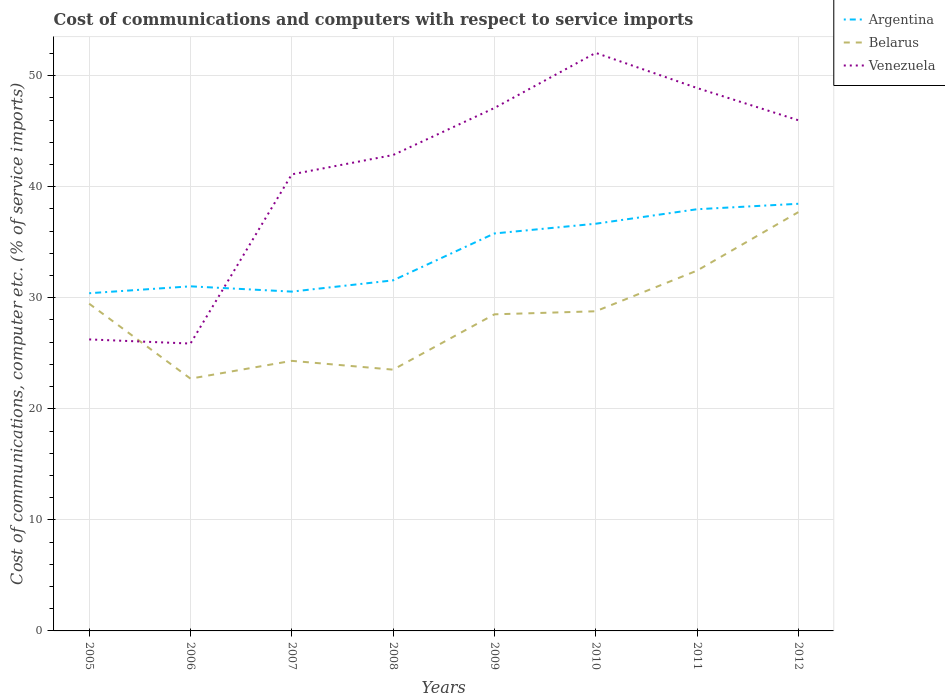How many different coloured lines are there?
Provide a succinct answer. 3. Does the line corresponding to Venezuela intersect with the line corresponding to Belarus?
Make the answer very short. Yes. Is the number of lines equal to the number of legend labels?
Your answer should be very brief. Yes. Across all years, what is the maximum cost of communications and computers in Argentina?
Offer a terse response. 30.41. In which year was the cost of communications and computers in Venezuela maximum?
Keep it short and to the point. 2006. What is the total cost of communications and computers in Belarus in the graph?
Offer a terse response. -1.6. What is the difference between the highest and the second highest cost of communications and computers in Argentina?
Offer a terse response. 8.05. What is the difference between the highest and the lowest cost of communications and computers in Argentina?
Your response must be concise. 4. Is the cost of communications and computers in Argentina strictly greater than the cost of communications and computers in Venezuela over the years?
Your response must be concise. No. What is the difference between two consecutive major ticks on the Y-axis?
Give a very brief answer. 10. Are the values on the major ticks of Y-axis written in scientific E-notation?
Make the answer very short. No. Does the graph contain grids?
Your answer should be compact. Yes. Where does the legend appear in the graph?
Your answer should be compact. Top right. How many legend labels are there?
Provide a short and direct response. 3. How are the legend labels stacked?
Offer a very short reply. Vertical. What is the title of the graph?
Give a very brief answer. Cost of communications and computers with respect to service imports. Does "Bangladesh" appear as one of the legend labels in the graph?
Your answer should be very brief. No. What is the label or title of the X-axis?
Your answer should be compact. Years. What is the label or title of the Y-axis?
Make the answer very short. Cost of communications, computer etc. (% of service imports). What is the Cost of communications, computer etc. (% of service imports) in Argentina in 2005?
Provide a short and direct response. 30.41. What is the Cost of communications, computer etc. (% of service imports) of Belarus in 2005?
Keep it short and to the point. 29.47. What is the Cost of communications, computer etc. (% of service imports) in Venezuela in 2005?
Your response must be concise. 26.25. What is the Cost of communications, computer etc. (% of service imports) in Argentina in 2006?
Your response must be concise. 31.03. What is the Cost of communications, computer etc. (% of service imports) of Belarus in 2006?
Provide a short and direct response. 22.72. What is the Cost of communications, computer etc. (% of service imports) in Venezuela in 2006?
Keep it short and to the point. 25.88. What is the Cost of communications, computer etc. (% of service imports) in Argentina in 2007?
Ensure brevity in your answer.  30.55. What is the Cost of communications, computer etc. (% of service imports) of Belarus in 2007?
Provide a short and direct response. 24.32. What is the Cost of communications, computer etc. (% of service imports) of Venezuela in 2007?
Your answer should be compact. 41.11. What is the Cost of communications, computer etc. (% of service imports) of Argentina in 2008?
Make the answer very short. 31.57. What is the Cost of communications, computer etc. (% of service imports) in Belarus in 2008?
Your answer should be very brief. 23.53. What is the Cost of communications, computer etc. (% of service imports) in Venezuela in 2008?
Provide a succinct answer. 42.85. What is the Cost of communications, computer etc. (% of service imports) in Argentina in 2009?
Provide a succinct answer. 35.79. What is the Cost of communications, computer etc. (% of service imports) in Belarus in 2009?
Your answer should be very brief. 28.51. What is the Cost of communications, computer etc. (% of service imports) of Venezuela in 2009?
Offer a terse response. 47.09. What is the Cost of communications, computer etc. (% of service imports) in Argentina in 2010?
Keep it short and to the point. 36.67. What is the Cost of communications, computer etc. (% of service imports) of Belarus in 2010?
Offer a terse response. 28.78. What is the Cost of communications, computer etc. (% of service imports) of Venezuela in 2010?
Offer a very short reply. 52.05. What is the Cost of communications, computer etc. (% of service imports) of Argentina in 2011?
Make the answer very short. 37.97. What is the Cost of communications, computer etc. (% of service imports) in Belarus in 2011?
Provide a short and direct response. 32.44. What is the Cost of communications, computer etc. (% of service imports) of Venezuela in 2011?
Offer a terse response. 48.89. What is the Cost of communications, computer etc. (% of service imports) in Argentina in 2012?
Give a very brief answer. 38.46. What is the Cost of communications, computer etc. (% of service imports) in Belarus in 2012?
Provide a short and direct response. 37.71. What is the Cost of communications, computer etc. (% of service imports) of Venezuela in 2012?
Ensure brevity in your answer.  45.98. Across all years, what is the maximum Cost of communications, computer etc. (% of service imports) of Argentina?
Provide a short and direct response. 38.46. Across all years, what is the maximum Cost of communications, computer etc. (% of service imports) in Belarus?
Provide a succinct answer. 37.71. Across all years, what is the maximum Cost of communications, computer etc. (% of service imports) of Venezuela?
Give a very brief answer. 52.05. Across all years, what is the minimum Cost of communications, computer etc. (% of service imports) of Argentina?
Make the answer very short. 30.41. Across all years, what is the minimum Cost of communications, computer etc. (% of service imports) in Belarus?
Your answer should be compact. 22.72. Across all years, what is the minimum Cost of communications, computer etc. (% of service imports) of Venezuela?
Offer a very short reply. 25.88. What is the total Cost of communications, computer etc. (% of service imports) of Argentina in the graph?
Offer a very short reply. 272.45. What is the total Cost of communications, computer etc. (% of service imports) of Belarus in the graph?
Keep it short and to the point. 227.47. What is the total Cost of communications, computer etc. (% of service imports) in Venezuela in the graph?
Keep it short and to the point. 330.1. What is the difference between the Cost of communications, computer etc. (% of service imports) in Argentina in 2005 and that in 2006?
Provide a succinct answer. -0.62. What is the difference between the Cost of communications, computer etc. (% of service imports) in Belarus in 2005 and that in 2006?
Offer a terse response. 6.75. What is the difference between the Cost of communications, computer etc. (% of service imports) in Venezuela in 2005 and that in 2006?
Provide a succinct answer. 0.37. What is the difference between the Cost of communications, computer etc. (% of service imports) in Argentina in 2005 and that in 2007?
Provide a succinct answer. -0.15. What is the difference between the Cost of communications, computer etc. (% of service imports) in Belarus in 2005 and that in 2007?
Your answer should be compact. 5.15. What is the difference between the Cost of communications, computer etc. (% of service imports) in Venezuela in 2005 and that in 2007?
Provide a short and direct response. -14.86. What is the difference between the Cost of communications, computer etc. (% of service imports) of Argentina in 2005 and that in 2008?
Keep it short and to the point. -1.16. What is the difference between the Cost of communications, computer etc. (% of service imports) in Belarus in 2005 and that in 2008?
Your answer should be compact. 5.94. What is the difference between the Cost of communications, computer etc. (% of service imports) of Venezuela in 2005 and that in 2008?
Provide a short and direct response. -16.6. What is the difference between the Cost of communications, computer etc. (% of service imports) of Argentina in 2005 and that in 2009?
Keep it short and to the point. -5.38. What is the difference between the Cost of communications, computer etc. (% of service imports) in Belarus in 2005 and that in 2009?
Your response must be concise. 0.96. What is the difference between the Cost of communications, computer etc. (% of service imports) of Venezuela in 2005 and that in 2009?
Your answer should be compact. -20.84. What is the difference between the Cost of communications, computer etc. (% of service imports) in Argentina in 2005 and that in 2010?
Offer a very short reply. -6.26. What is the difference between the Cost of communications, computer etc. (% of service imports) in Belarus in 2005 and that in 2010?
Make the answer very short. 0.68. What is the difference between the Cost of communications, computer etc. (% of service imports) in Venezuela in 2005 and that in 2010?
Your answer should be very brief. -25.8. What is the difference between the Cost of communications, computer etc. (% of service imports) in Argentina in 2005 and that in 2011?
Give a very brief answer. -7.56. What is the difference between the Cost of communications, computer etc. (% of service imports) in Belarus in 2005 and that in 2011?
Your answer should be very brief. -2.98. What is the difference between the Cost of communications, computer etc. (% of service imports) in Venezuela in 2005 and that in 2011?
Ensure brevity in your answer.  -22.64. What is the difference between the Cost of communications, computer etc. (% of service imports) in Argentina in 2005 and that in 2012?
Offer a terse response. -8.05. What is the difference between the Cost of communications, computer etc. (% of service imports) of Belarus in 2005 and that in 2012?
Your response must be concise. -8.24. What is the difference between the Cost of communications, computer etc. (% of service imports) in Venezuela in 2005 and that in 2012?
Provide a succinct answer. -19.73. What is the difference between the Cost of communications, computer etc. (% of service imports) of Argentina in 2006 and that in 2007?
Give a very brief answer. 0.48. What is the difference between the Cost of communications, computer etc. (% of service imports) in Belarus in 2006 and that in 2007?
Give a very brief answer. -1.6. What is the difference between the Cost of communications, computer etc. (% of service imports) in Venezuela in 2006 and that in 2007?
Your answer should be compact. -15.24. What is the difference between the Cost of communications, computer etc. (% of service imports) in Argentina in 2006 and that in 2008?
Offer a terse response. -0.54. What is the difference between the Cost of communications, computer etc. (% of service imports) of Belarus in 2006 and that in 2008?
Make the answer very short. -0.81. What is the difference between the Cost of communications, computer etc. (% of service imports) of Venezuela in 2006 and that in 2008?
Give a very brief answer. -16.98. What is the difference between the Cost of communications, computer etc. (% of service imports) of Argentina in 2006 and that in 2009?
Provide a short and direct response. -4.76. What is the difference between the Cost of communications, computer etc. (% of service imports) of Belarus in 2006 and that in 2009?
Ensure brevity in your answer.  -5.79. What is the difference between the Cost of communications, computer etc. (% of service imports) in Venezuela in 2006 and that in 2009?
Your answer should be compact. -21.21. What is the difference between the Cost of communications, computer etc. (% of service imports) of Argentina in 2006 and that in 2010?
Your response must be concise. -5.64. What is the difference between the Cost of communications, computer etc. (% of service imports) of Belarus in 2006 and that in 2010?
Make the answer very short. -6.07. What is the difference between the Cost of communications, computer etc. (% of service imports) of Venezuela in 2006 and that in 2010?
Your answer should be compact. -26.18. What is the difference between the Cost of communications, computer etc. (% of service imports) in Argentina in 2006 and that in 2011?
Provide a succinct answer. -6.94. What is the difference between the Cost of communications, computer etc. (% of service imports) of Belarus in 2006 and that in 2011?
Your answer should be compact. -9.73. What is the difference between the Cost of communications, computer etc. (% of service imports) in Venezuela in 2006 and that in 2011?
Keep it short and to the point. -23.01. What is the difference between the Cost of communications, computer etc. (% of service imports) in Argentina in 2006 and that in 2012?
Keep it short and to the point. -7.43. What is the difference between the Cost of communications, computer etc. (% of service imports) in Belarus in 2006 and that in 2012?
Ensure brevity in your answer.  -14.99. What is the difference between the Cost of communications, computer etc. (% of service imports) in Venezuela in 2006 and that in 2012?
Offer a terse response. -20.11. What is the difference between the Cost of communications, computer etc. (% of service imports) of Argentina in 2007 and that in 2008?
Offer a terse response. -1.01. What is the difference between the Cost of communications, computer etc. (% of service imports) in Belarus in 2007 and that in 2008?
Provide a short and direct response. 0.79. What is the difference between the Cost of communications, computer etc. (% of service imports) in Venezuela in 2007 and that in 2008?
Make the answer very short. -1.74. What is the difference between the Cost of communications, computer etc. (% of service imports) in Argentina in 2007 and that in 2009?
Offer a very short reply. -5.24. What is the difference between the Cost of communications, computer etc. (% of service imports) in Belarus in 2007 and that in 2009?
Provide a short and direct response. -4.19. What is the difference between the Cost of communications, computer etc. (% of service imports) of Venezuela in 2007 and that in 2009?
Provide a short and direct response. -5.97. What is the difference between the Cost of communications, computer etc. (% of service imports) of Argentina in 2007 and that in 2010?
Provide a succinct answer. -6.11. What is the difference between the Cost of communications, computer etc. (% of service imports) of Belarus in 2007 and that in 2010?
Your answer should be compact. -4.46. What is the difference between the Cost of communications, computer etc. (% of service imports) in Venezuela in 2007 and that in 2010?
Your answer should be very brief. -10.94. What is the difference between the Cost of communications, computer etc. (% of service imports) of Argentina in 2007 and that in 2011?
Keep it short and to the point. -7.42. What is the difference between the Cost of communications, computer etc. (% of service imports) of Belarus in 2007 and that in 2011?
Make the answer very short. -8.13. What is the difference between the Cost of communications, computer etc. (% of service imports) of Venezuela in 2007 and that in 2011?
Ensure brevity in your answer.  -7.77. What is the difference between the Cost of communications, computer etc. (% of service imports) of Argentina in 2007 and that in 2012?
Give a very brief answer. -7.91. What is the difference between the Cost of communications, computer etc. (% of service imports) of Belarus in 2007 and that in 2012?
Offer a terse response. -13.39. What is the difference between the Cost of communications, computer etc. (% of service imports) of Venezuela in 2007 and that in 2012?
Your answer should be compact. -4.87. What is the difference between the Cost of communications, computer etc. (% of service imports) in Argentina in 2008 and that in 2009?
Keep it short and to the point. -4.22. What is the difference between the Cost of communications, computer etc. (% of service imports) in Belarus in 2008 and that in 2009?
Offer a terse response. -4.98. What is the difference between the Cost of communications, computer etc. (% of service imports) in Venezuela in 2008 and that in 2009?
Your answer should be compact. -4.23. What is the difference between the Cost of communications, computer etc. (% of service imports) of Argentina in 2008 and that in 2010?
Your answer should be compact. -5.1. What is the difference between the Cost of communications, computer etc. (% of service imports) in Belarus in 2008 and that in 2010?
Your answer should be very brief. -5.26. What is the difference between the Cost of communications, computer etc. (% of service imports) in Venezuela in 2008 and that in 2010?
Keep it short and to the point. -9.2. What is the difference between the Cost of communications, computer etc. (% of service imports) in Argentina in 2008 and that in 2011?
Offer a very short reply. -6.4. What is the difference between the Cost of communications, computer etc. (% of service imports) in Belarus in 2008 and that in 2011?
Keep it short and to the point. -8.92. What is the difference between the Cost of communications, computer etc. (% of service imports) of Venezuela in 2008 and that in 2011?
Make the answer very short. -6.03. What is the difference between the Cost of communications, computer etc. (% of service imports) of Argentina in 2008 and that in 2012?
Ensure brevity in your answer.  -6.9. What is the difference between the Cost of communications, computer etc. (% of service imports) in Belarus in 2008 and that in 2012?
Give a very brief answer. -14.18. What is the difference between the Cost of communications, computer etc. (% of service imports) of Venezuela in 2008 and that in 2012?
Ensure brevity in your answer.  -3.13. What is the difference between the Cost of communications, computer etc. (% of service imports) of Argentina in 2009 and that in 2010?
Ensure brevity in your answer.  -0.88. What is the difference between the Cost of communications, computer etc. (% of service imports) in Belarus in 2009 and that in 2010?
Provide a succinct answer. -0.28. What is the difference between the Cost of communications, computer etc. (% of service imports) of Venezuela in 2009 and that in 2010?
Provide a succinct answer. -4.96. What is the difference between the Cost of communications, computer etc. (% of service imports) of Argentina in 2009 and that in 2011?
Give a very brief answer. -2.18. What is the difference between the Cost of communications, computer etc. (% of service imports) of Belarus in 2009 and that in 2011?
Offer a very short reply. -3.94. What is the difference between the Cost of communications, computer etc. (% of service imports) in Venezuela in 2009 and that in 2011?
Your response must be concise. -1.8. What is the difference between the Cost of communications, computer etc. (% of service imports) of Argentina in 2009 and that in 2012?
Provide a short and direct response. -2.67. What is the difference between the Cost of communications, computer etc. (% of service imports) of Belarus in 2009 and that in 2012?
Give a very brief answer. -9.2. What is the difference between the Cost of communications, computer etc. (% of service imports) in Venezuela in 2009 and that in 2012?
Give a very brief answer. 1.1. What is the difference between the Cost of communications, computer etc. (% of service imports) in Argentina in 2010 and that in 2011?
Provide a short and direct response. -1.3. What is the difference between the Cost of communications, computer etc. (% of service imports) of Belarus in 2010 and that in 2011?
Your answer should be compact. -3.66. What is the difference between the Cost of communications, computer etc. (% of service imports) of Venezuela in 2010 and that in 2011?
Your answer should be very brief. 3.16. What is the difference between the Cost of communications, computer etc. (% of service imports) in Argentina in 2010 and that in 2012?
Give a very brief answer. -1.8. What is the difference between the Cost of communications, computer etc. (% of service imports) of Belarus in 2010 and that in 2012?
Offer a terse response. -8.93. What is the difference between the Cost of communications, computer etc. (% of service imports) of Venezuela in 2010 and that in 2012?
Ensure brevity in your answer.  6.07. What is the difference between the Cost of communications, computer etc. (% of service imports) of Argentina in 2011 and that in 2012?
Offer a terse response. -0.49. What is the difference between the Cost of communications, computer etc. (% of service imports) in Belarus in 2011 and that in 2012?
Offer a very short reply. -5.26. What is the difference between the Cost of communications, computer etc. (% of service imports) of Venezuela in 2011 and that in 2012?
Your answer should be compact. 2.9. What is the difference between the Cost of communications, computer etc. (% of service imports) in Argentina in 2005 and the Cost of communications, computer etc. (% of service imports) in Belarus in 2006?
Your answer should be compact. 7.69. What is the difference between the Cost of communications, computer etc. (% of service imports) of Argentina in 2005 and the Cost of communications, computer etc. (% of service imports) of Venezuela in 2006?
Offer a terse response. 4.53. What is the difference between the Cost of communications, computer etc. (% of service imports) of Belarus in 2005 and the Cost of communications, computer etc. (% of service imports) of Venezuela in 2006?
Your answer should be compact. 3.59. What is the difference between the Cost of communications, computer etc. (% of service imports) of Argentina in 2005 and the Cost of communications, computer etc. (% of service imports) of Belarus in 2007?
Provide a short and direct response. 6.09. What is the difference between the Cost of communications, computer etc. (% of service imports) in Argentina in 2005 and the Cost of communications, computer etc. (% of service imports) in Venezuela in 2007?
Provide a short and direct response. -10.7. What is the difference between the Cost of communications, computer etc. (% of service imports) in Belarus in 2005 and the Cost of communications, computer etc. (% of service imports) in Venezuela in 2007?
Your response must be concise. -11.65. What is the difference between the Cost of communications, computer etc. (% of service imports) of Argentina in 2005 and the Cost of communications, computer etc. (% of service imports) of Belarus in 2008?
Provide a short and direct response. 6.88. What is the difference between the Cost of communications, computer etc. (% of service imports) in Argentina in 2005 and the Cost of communications, computer etc. (% of service imports) in Venezuela in 2008?
Your response must be concise. -12.45. What is the difference between the Cost of communications, computer etc. (% of service imports) of Belarus in 2005 and the Cost of communications, computer etc. (% of service imports) of Venezuela in 2008?
Your answer should be very brief. -13.39. What is the difference between the Cost of communications, computer etc. (% of service imports) in Argentina in 2005 and the Cost of communications, computer etc. (% of service imports) in Belarus in 2009?
Your answer should be very brief. 1.9. What is the difference between the Cost of communications, computer etc. (% of service imports) of Argentina in 2005 and the Cost of communications, computer etc. (% of service imports) of Venezuela in 2009?
Provide a short and direct response. -16.68. What is the difference between the Cost of communications, computer etc. (% of service imports) of Belarus in 2005 and the Cost of communications, computer etc. (% of service imports) of Venezuela in 2009?
Make the answer very short. -17.62. What is the difference between the Cost of communications, computer etc. (% of service imports) of Argentina in 2005 and the Cost of communications, computer etc. (% of service imports) of Belarus in 2010?
Keep it short and to the point. 1.62. What is the difference between the Cost of communications, computer etc. (% of service imports) of Argentina in 2005 and the Cost of communications, computer etc. (% of service imports) of Venezuela in 2010?
Ensure brevity in your answer.  -21.64. What is the difference between the Cost of communications, computer etc. (% of service imports) in Belarus in 2005 and the Cost of communications, computer etc. (% of service imports) in Venezuela in 2010?
Provide a short and direct response. -22.59. What is the difference between the Cost of communications, computer etc. (% of service imports) of Argentina in 2005 and the Cost of communications, computer etc. (% of service imports) of Belarus in 2011?
Keep it short and to the point. -2.04. What is the difference between the Cost of communications, computer etc. (% of service imports) in Argentina in 2005 and the Cost of communications, computer etc. (% of service imports) in Venezuela in 2011?
Your answer should be compact. -18.48. What is the difference between the Cost of communications, computer etc. (% of service imports) in Belarus in 2005 and the Cost of communications, computer etc. (% of service imports) in Venezuela in 2011?
Offer a very short reply. -19.42. What is the difference between the Cost of communications, computer etc. (% of service imports) in Argentina in 2005 and the Cost of communications, computer etc. (% of service imports) in Belarus in 2012?
Your answer should be compact. -7.3. What is the difference between the Cost of communications, computer etc. (% of service imports) in Argentina in 2005 and the Cost of communications, computer etc. (% of service imports) in Venezuela in 2012?
Provide a succinct answer. -15.58. What is the difference between the Cost of communications, computer etc. (% of service imports) in Belarus in 2005 and the Cost of communications, computer etc. (% of service imports) in Venezuela in 2012?
Provide a succinct answer. -16.52. What is the difference between the Cost of communications, computer etc. (% of service imports) in Argentina in 2006 and the Cost of communications, computer etc. (% of service imports) in Belarus in 2007?
Make the answer very short. 6.71. What is the difference between the Cost of communications, computer etc. (% of service imports) in Argentina in 2006 and the Cost of communications, computer etc. (% of service imports) in Venezuela in 2007?
Offer a very short reply. -10.08. What is the difference between the Cost of communications, computer etc. (% of service imports) of Belarus in 2006 and the Cost of communications, computer etc. (% of service imports) of Venezuela in 2007?
Offer a terse response. -18.4. What is the difference between the Cost of communications, computer etc. (% of service imports) of Argentina in 2006 and the Cost of communications, computer etc. (% of service imports) of Belarus in 2008?
Ensure brevity in your answer.  7.5. What is the difference between the Cost of communications, computer etc. (% of service imports) in Argentina in 2006 and the Cost of communications, computer etc. (% of service imports) in Venezuela in 2008?
Give a very brief answer. -11.82. What is the difference between the Cost of communications, computer etc. (% of service imports) of Belarus in 2006 and the Cost of communications, computer etc. (% of service imports) of Venezuela in 2008?
Provide a succinct answer. -20.14. What is the difference between the Cost of communications, computer etc. (% of service imports) in Argentina in 2006 and the Cost of communications, computer etc. (% of service imports) in Belarus in 2009?
Your answer should be very brief. 2.52. What is the difference between the Cost of communications, computer etc. (% of service imports) in Argentina in 2006 and the Cost of communications, computer etc. (% of service imports) in Venezuela in 2009?
Make the answer very short. -16.06. What is the difference between the Cost of communications, computer etc. (% of service imports) in Belarus in 2006 and the Cost of communications, computer etc. (% of service imports) in Venezuela in 2009?
Provide a succinct answer. -24.37. What is the difference between the Cost of communications, computer etc. (% of service imports) of Argentina in 2006 and the Cost of communications, computer etc. (% of service imports) of Belarus in 2010?
Your answer should be compact. 2.25. What is the difference between the Cost of communications, computer etc. (% of service imports) in Argentina in 2006 and the Cost of communications, computer etc. (% of service imports) in Venezuela in 2010?
Make the answer very short. -21.02. What is the difference between the Cost of communications, computer etc. (% of service imports) of Belarus in 2006 and the Cost of communications, computer etc. (% of service imports) of Venezuela in 2010?
Offer a very short reply. -29.34. What is the difference between the Cost of communications, computer etc. (% of service imports) in Argentina in 2006 and the Cost of communications, computer etc. (% of service imports) in Belarus in 2011?
Keep it short and to the point. -1.41. What is the difference between the Cost of communications, computer etc. (% of service imports) of Argentina in 2006 and the Cost of communications, computer etc. (% of service imports) of Venezuela in 2011?
Your answer should be very brief. -17.86. What is the difference between the Cost of communications, computer etc. (% of service imports) of Belarus in 2006 and the Cost of communications, computer etc. (% of service imports) of Venezuela in 2011?
Provide a succinct answer. -26.17. What is the difference between the Cost of communications, computer etc. (% of service imports) of Argentina in 2006 and the Cost of communications, computer etc. (% of service imports) of Belarus in 2012?
Your response must be concise. -6.68. What is the difference between the Cost of communications, computer etc. (% of service imports) of Argentina in 2006 and the Cost of communications, computer etc. (% of service imports) of Venezuela in 2012?
Make the answer very short. -14.95. What is the difference between the Cost of communications, computer etc. (% of service imports) of Belarus in 2006 and the Cost of communications, computer etc. (% of service imports) of Venezuela in 2012?
Provide a succinct answer. -23.27. What is the difference between the Cost of communications, computer etc. (% of service imports) of Argentina in 2007 and the Cost of communications, computer etc. (% of service imports) of Belarus in 2008?
Your answer should be very brief. 7.03. What is the difference between the Cost of communications, computer etc. (% of service imports) in Argentina in 2007 and the Cost of communications, computer etc. (% of service imports) in Venezuela in 2008?
Your response must be concise. -12.3. What is the difference between the Cost of communications, computer etc. (% of service imports) of Belarus in 2007 and the Cost of communications, computer etc. (% of service imports) of Venezuela in 2008?
Keep it short and to the point. -18.53. What is the difference between the Cost of communications, computer etc. (% of service imports) of Argentina in 2007 and the Cost of communications, computer etc. (% of service imports) of Belarus in 2009?
Keep it short and to the point. 2.05. What is the difference between the Cost of communications, computer etc. (% of service imports) in Argentina in 2007 and the Cost of communications, computer etc. (% of service imports) in Venezuela in 2009?
Give a very brief answer. -16.53. What is the difference between the Cost of communications, computer etc. (% of service imports) in Belarus in 2007 and the Cost of communications, computer etc. (% of service imports) in Venezuela in 2009?
Offer a terse response. -22.77. What is the difference between the Cost of communications, computer etc. (% of service imports) of Argentina in 2007 and the Cost of communications, computer etc. (% of service imports) of Belarus in 2010?
Give a very brief answer. 1.77. What is the difference between the Cost of communications, computer etc. (% of service imports) of Argentina in 2007 and the Cost of communications, computer etc. (% of service imports) of Venezuela in 2010?
Ensure brevity in your answer.  -21.5. What is the difference between the Cost of communications, computer etc. (% of service imports) in Belarus in 2007 and the Cost of communications, computer etc. (% of service imports) in Venezuela in 2010?
Offer a very short reply. -27.73. What is the difference between the Cost of communications, computer etc. (% of service imports) in Argentina in 2007 and the Cost of communications, computer etc. (% of service imports) in Belarus in 2011?
Offer a very short reply. -1.89. What is the difference between the Cost of communications, computer etc. (% of service imports) of Argentina in 2007 and the Cost of communications, computer etc. (% of service imports) of Venezuela in 2011?
Provide a short and direct response. -18.33. What is the difference between the Cost of communications, computer etc. (% of service imports) of Belarus in 2007 and the Cost of communications, computer etc. (% of service imports) of Venezuela in 2011?
Keep it short and to the point. -24.57. What is the difference between the Cost of communications, computer etc. (% of service imports) of Argentina in 2007 and the Cost of communications, computer etc. (% of service imports) of Belarus in 2012?
Your response must be concise. -7.16. What is the difference between the Cost of communications, computer etc. (% of service imports) of Argentina in 2007 and the Cost of communications, computer etc. (% of service imports) of Venezuela in 2012?
Your answer should be very brief. -15.43. What is the difference between the Cost of communications, computer etc. (% of service imports) of Belarus in 2007 and the Cost of communications, computer etc. (% of service imports) of Venezuela in 2012?
Ensure brevity in your answer.  -21.66. What is the difference between the Cost of communications, computer etc. (% of service imports) in Argentina in 2008 and the Cost of communications, computer etc. (% of service imports) in Belarus in 2009?
Make the answer very short. 3.06. What is the difference between the Cost of communications, computer etc. (% of service imports) in Argentina in 2008 and the Cost of communications, computer etc. (% of service imports) in Venezuela in 2009?
Make the answer very short. -15.52. What is the difference between the Cost of communications, computer etc. (% of service imports) of Belarus in 2008 and the Cost of communications, computer etc. (% of service imports) of Venezuela in 2009?
Your response must be concise. -23.56. What is the difference between the Cost of communications, computer etc. (% of service imports) of Argentina in 2008 and the Cost of communications, computer etc. (% of service imports) of Belarus in 2010?
Provide a succinct answer. 2.78. What is the difference between the Cost of communications, computer etc. (% of service imports) in Argentina in 2008 and the Cost of communications, computer etc. (% of service imports) in Venezuela in 2010?
Offer a terse response. -20.48. What is the difference between the Cost of communications, computer etc. (% of service imports) of Belarus in 2008 and the Cost of communications, computer etc. (% of service imports) of Venezuela in 2010?
Give a very brief answer. -28.53. What is the difference between the Cost of communications, computer etc. (% of service imports) in Argentina in 2008 and the Cost of communications, computer etc. (% of service imports) in Belarus in 2011?
Provide a succinct answer. -0.88. What is the difference between the Cost of communications, computer etc. (% of service imports) of Argentina in 2008 and the Cost of communications, computer etc. (% of service imports) of Venezuela in 2011?
Give a very brief answer. -17.32. What is the difference between the Cost of communications, computer etc. (% of service imports) in Belarus in 2008 and the Cost of communications, computer etc. (% of service imports) in Venezuela in 2011?
Provide a short and direct response. -25.36. What is the difference between the Cost of communications, computer etc. (% of service imports) in Argentina in 2008 and the Cost of communications, computer etc. (% of service imports) in Belarus in 2012?
Offer a terse response. -6.14. What is the difference between the Cost of communications, computer etc. (% of service imports) in Argentina in 2008 and the Cost of communications, computer etc. (% of service imports) in Venezuela in 2012?
Make the answer very short. -14.42. What is the difference between the Cost of communications, computer etc. (% of service imports) in Belarus in 2008 and the Cost of communications, computer etc. (% of service imports) in Venezuela in 2012?
Keep it short and to the point. -22.46. What is the difference between the Cost of communications, computer etc. (% of service imports) of Argentina in 2009 and the Cost of communications, computer etc. (% of service imports) of Belarus in 2010?
Your answer should be compact. 7.01. What is the difference between the Cost of communications, computer etc. (% of service imports) in Argentina in 2009 and the Cost of communications, computer etc. (% of service imports) in Venezuela in 2010?
Provide a short and direct response. -16.26. What is the difference between the Cost of communications, computer etc. (% of service imports) of Belarus in 2009 and the Cost of communications, computer etc. (% of service imports) of Venezuela in 2010?
Offer a very short reply. -23.54. What is the difference between the Cost of communications, computer etc. (% of service imports) of Argentina in 2009 and the Cost of communications, computer etc. (% of service imports) of Belarus in 2011?
Your answer should be very brief. 3.34. What is the difference between the Cost of communications, computer etc. (% of service imports) of Argentina in 2009 and the Cost of communications, computer etc. (% of service imports) of Venezuela in 2011?
Your answer should be very brief. -13.1. What is the difference between the Cost of communications, computer etc. (% of service imports) of Belarus in 2009 and the Cost of communications, computer etc. (% of service imports) of Venezuela in 2011?
Provide a short and direct response. -20.38. What is the difference between the Cost of communications, computer etc. (% of service imports) in Argentina in 2009 and the Cost of communications, computer etc. (% of service imports) in Belarus in 2012?
Your response must be concise. -1.92. What is the difference between the Cost of communications, computer etc. (% of service imports) of Argentina in 2009 and the Cost of communications, computer etc. (% of service imports) of Venezuela in 2012?
Offer a very short reply. -10.19. What is the difference between the Cost of communications, computer etc. (% of service imports) of Belarus in 2009 and the Cost of communications, computer etc. (% of service imports) of Venezuela in 2012?
Offer a very short reply. -17.48. What is the difference between the Cost of communications, computer etc. (% of service imports) of Argentina in 2010 and the Cost of communications, computer etc. (% of service imports) of Belarus in 2011?
Offer a very short reply. 4.22. What is the difference between the Cost of communications, computer etc. (% of service imports) of Argentina in 2010 and the Cost of communications, computer etc. (% of service imports) of Venezuela in 2011?
Offer a very short reply. -12.22. What is the difference between the Cost of communications, computer etc. (% of service imports) in Belarus in 2010 and the Cost of communications, computer etc. (% of service imports) in Venezuela in 2011?
Keep it short and to the point. -20.1. What is the difference between the Cost of communications, computer etc. (% of service imports) of Argentina in 2010 and the Cost of communications, computer etc. (% of service imports) of Belarus in 2012?
Provide a short and direct response. -1.04. What is the difference between the Cost of communications, computer etc. (% of service imports) in Argentina in 2010 and the Cost of communications, computer etc. (% of service imports) in Venezuela in 2012?
Offer a very short reply. -9.32. What is the difference between the Cost of communications, computer etc. (% of service imports) of Belarus in 2010 and the Cost of communications, computer etc. (% of service imports) of Venezuela in 2012?
Provide a succinct answer. -17.2. What is the difference between the Cost of communications, computer etc. (% of service imports) in Argentina in 2011 and the Cost of communications, computer etc. (% of service imports) in Belarus in 2012?
Offer a very short reply. 0.26. What is the difference between the Cost of communications, computer etc. (% of service imports) in Argentina in 2011 and the Cost of communications, computer etc. (% of service imports) in Venezuela in 2012?
Ensure brevity in your answer.  -8.01. What is the difference between the Cost of communications, computer etc. (% of service imports) in Belarus in 2011 and the Cost of communications, computer etc. (% of service imports) in Venezuela in 2012?
Offer a terse response. -13.54. What is the average Cost of communications, computer etc. (% of service imports) of Argentina per year?
Offer a very short reply. 34.06. What is the average Cost of communications, computer etc. (% of service imports) in Belarus per year?
Your answer should be compact. 28.43. What is the average Cost of communications, computer etc. (% of service imports) in Venezuela per year?
Ensure brevity in your answer.  41.26. In the year 2005, what is the difference between the Cost of communications, computer etc. (% of service imports) of Argentina and Cost of communications, computer etc. (% of service imports) of Belarus?
Your response must be concise. 0.94. In the year 2005, what is the difference between the Cost of communications, computer etc. (% of service imports) in Argentina and Cost of communications, computer etc. (% of service imports) in Venezuela?
Keep it short and to the point. 4.16. In the year 2005, what is the difference between the Cost of communications, computer etc. (% of service imports) in Belarus and Cost of communications, computer etc. (% of service imports) in Venezuela?
Provide a short and direct response. 3.22. In the year 2006, what is the difference between the Cost of communications, computer etc. (% of service imports) of Argentina and Cost of communications, computer etc. (% of service imports) of Belarus?
Give a very brief answer. 8.31. In the year 2006, what is the difference between the Cost of communications, computer etc. (% of service imports) of Argentina and Cost of communications, computer etc. (% of service imports) of Venezuela?
Your response must be concise. 5.15. In the year 2006, what is the difference between the Cost of communications, computer etc. (% of service imports) in Belarus and Cost of communications, computer etc. (% of service imports) in Venezuela?
Your response must be concise. -3.16. In the year 2007, what is the difference between the Cost of communications, computer etc. (% of service imports) in Argentina and Cost of communications, computer etc. (% of service imports) in Belarus?
Offer a terse response. 6.23. In the year 2007, what is the difference between the Cost of communications, computer etc. (% of service imports) of Argentina and Cost of communications, computer etc. (% of service imports) of Venezuela?
Your answer should be compact. -10.56. In the year 2007, what is the difference between the Cost of communications, computer etc. (% of service imports) of Belarus and Cost of communications, computer etc. (% of service imports) of Venezuela?
Make the answer very short. -16.79. In the year 2008, what is the difference between the Cost of communications, computer etc. (% of service imports) of Argentina and Cost of communications, computer etc. (% of service imports) of Belarus?
Provide a succinct answer. 8.04. In the year 2008, what is the difference between the Cost of communications, computer etc. (% of service imports) of Argentina and Cost of communications, computer etc. (% of service imports) of Venezuela?
Provide a short and direct response. -11.29. In the year 2008, what is the difference between the Cost of communications, computer etc. (% of service imports) of Belarus and Cost of communications, computer etc. (% of service imports) of Venezuela?
Your answer should be very brief. -19.33. In the year 2009, what is the difference between the Cost of communications, computer etc. (% of service imports) of Argentina and Cost of communications, computer etc. (% of service imports) of Belarus?
Make the answer very short. 7.28. In the year 2009, what is the difference between the Cost of communications, computer etc. (% of service imports) of Argentina and Cost of communications, computer etc. (% of service imports) of Venezuela?
Provide a short and direct response. -11.3. In the year 2009, what is the difference between the Cost of communications, computer etc. (% of service imports) of Belarus and Cost of communications, computer etc. (% of service imports) of Venezuela?
Make the answer very short. -18.58. In the year 2010, what is the difference between the Cost of communications, computer etc. (% of service imports) of Argentina and Cost of communications, computer etc. (% of service imports) of Belarus?
Provide a short and direct response. 7.88. In the year 2010, what is the difference between the Cost of communications, computer etc. (% of service imports) in Argentina and Cost of communications, computer etc. (% of service imports) in Venezuela?
Offer a very short reply. -15.39. In the year 2010, what is the difference between the Cost of communications, computer etc. (% of service imports) in Belarus and Cost of communications, computer etc. (% of service imports) in Venezuela?
Give a very brief answer. -23.27. In the year 2011, what is the difference between the Cost of communications, computer etc. (% of service imports) in Argentina and Cost of communications, computer etc. (% of service imports) in Belarus?
Ensure brevity in your answer.  5.53. In the year 2011, what is the difference between the Cost of communications, computer etc. (% of service imports) of Argentina and Cost of communications, computer etc. (% of service imports) of Venezuela?
Provide a short and direct response. -10.92. In the year 2011, what is the difference between the Cost of communications, computer etc. (% of service imports) of Belarus and Cost of communications, computer etc. (% of service imports) of Venezuela?
Your response must be concise. -16.44. In the year 2012, what is the difference between the Cost of communications, computer etc. (% of service imports) of Argentina and Cost of communications, computer etc. (% of service imports) of Belarus?
Give a very brief answer. 0.75. In the year 2012, what is the difference between the Cost of communications, computer etc. (% of service imports) in Argentina and Cost of communications, computer etc. (% of service imports) in Venezuela?
Provide a succinct answer. -7.52. In the year 2012, what is the difference between the Cost of communications, computer etc. (% of service imports) in Belarus and Cost of communications, computer etc. (% of service imports) in Venezuela?
Ensure brevity in your answer.  -8.27. What is the ratio of the Cost of communications, computer etc. (% of service imports) of Belarus in 2005 to that in 2006?
Ensure brevity in your answer.  1.3. What is the ratio of the Cost of communications, computer etc. (% of service imports) of Venezuela in 2005 to that in 2006?
Your answer should be compact. 1.01. What is the ratio of the Cost of communications, computer etc. (% of service imports) of Argentina in 2005 to that in 2007?
Your response must be concise. 1. What is the ratio of the Cost of communications, computer etc. (% of service imports) of Belarus in 2005 to that in 2007?
Your answer should be very brief. 1.21. What is the ratio of the Cost of communications, computer etc. (% of service imports) in Venezuela in 2005 to that in 2007?
Offer a very short reply. 0.64. What is the ratio of the Cost of communications, computer etc. (% of service imports) in Argentina in 2005 to that in 2008?
Keep it short and to the point. 0.96. What is the ratio of the Cost of communications, computer etc. (% of service imports) in Belarus in 2005 to that in 2008?
Offer a very short reply. 1.25. What is the ratio of the Cost of communications, computer etc. (% of service imports) of Venezuela in 2005 to that in 2008?
Give a very brief answer. 0.61. What is the ratio of the Cost of communications, computer etc. (% of service imports) in Argentina in 2005 to that in 2009?
Give a very brief answer. 0.85. What is the ratio of the Cost of communications, computer etc. (% of service imports) in Belarus in 2005 to that in 2009?
Provide a succinct answer. 1.03. What is the ratio of the Cost of communications, computer etc. (% of service imports) in Venezuela in 2005 to that in 2009?
Ensure brevity in your answer.  0.56. What is the ratio of the Cost of communications, computer etc. (% of service imports) of Argentina in 2005 to that in 2010?
Provide a short and direct response. 0.83. What is the ratio of the Cost of communications, computer etc. (% of service imports) of Belarus in 2005 to that in 2010?
Give a very brief answer. 1.02. What is the ratio of the Cost of communications, computer etc. (% of service imports) in Venezuela in 2005 to that in 2010?
Keep it short and to the point. 0.5. What is the ratio of the Cost of communications, computer etc. (% of service imports) in Argentina in 2005 to that in 2011?
Provide a short and direct response. 0.8. What is the ratio of the Cost of communications, computer etc. (% of service imports) in Belarus in 2005 to that in 2011?
Provide a succinct answer. 0.91. What is the ratio of the Cost of communications, computer etc. (% of service imports) of Venezuela in 2005 to that in 2011?
Your answer should be compact. 0.54. What is the ratio of the Cost of communications, computer etc. (% of service imports) in Argentina in 2005 to that in 2012?
Give a very brief answer. 0.79. What is the ratio of the Cost of communications, computer etc. (% of service imports) of Belarus in 2005 to that in 2012?
Give a very brief answer. 0.78. What is the ratio of the Cost of communications, computer etc. (% of service imports) in Venezuela in 2005 to that in 2012?
Ensure brevity in your answer.  0.57. What is the ratio of the Cost of communications, computer etc. (% of service imports) of Argentina in 2006 to that in 2007?
Keep it short and to the point. 1.02. What is the ratio of the Cost of communications, computer etc. (% of service imports) of Belarus in 2006 to that in 2007?
Give a very brief answer. 0.93. What is the ratio of the Cost of communications, computer etc. (% of service imports) in Venezuela in 2006 to that in 2007?
Give a very brief answer. 0.63. What is the ratio of the Cost of communications, computer etc. (% of service imports) in Argentina in 2006 to that in 2008?
Give a very brief answer. 0.98. What is the ratio of the Cost of communications, computer etc. (% of service imports) of Belarus in 2006 to that in 2008?
Offer a very short reply. 0.97. What is the ratio of the Cost of communications, computer etc. (% of service imports) in Venezuela in 2006 to that in 2008?
Provide a short and direct response. 0.6. What is the ratio of the Cost of communications, computer etc. (% of service imports) in Argentina in 2006 to that in 2009?
Make the answer very short. 0.87. What is the ratio of the Cost of communications, computer etc. (% of service imports) in Belarus in 2006 to that in 2009?
Offer a very short reply. 0.8. What is the ratio of the Cost of communications, computer etc. (% of service imports) in Venezuela in 2006 to that in 2009?
Ensure brevity in your answer.  0.55. What is the ratio of the Cost of communications, computer etc. (% of service imports) of Argentina in 2006 to that in 2010?
Give a very brief answer. 0.85. What is the ratio of the Cost of communications, computer etc. (% of service imports) in Belarus in 2006 to that in 2010?
Give a very brief answer. 0.79. What is the ratio of the Cost of communications, computer etc. (% of service imports) in Venezuela in 2006 to that in 2010?
Make the answer very short. 0.5. What is the ratio of the Cost of communications, computer etc. (% of service imports) in Argentina in 2006 to that in 2011?
Make the answer very short. 0.82. What is the ratio of the Cost of communications, computer etc. (% of service imports) of Belarus in 2006 to that in 2011?
Give a very brief answer. 0.7. What is the ratio of the Cost of communications, computer etc. (% of service imports) in Venezuela in 2006 to that in 2011?
Provide a succinct answer. 0.53. What is the ratio of the Cost of communications, computer etc. (% of service imports) of Argentina in 2006 to that in 2012?
Your response must be concise. 0.81. What is the ratio of the Cost of communications, computer etc. (% of service imports) in Belarus in 2006 to that in 2012?
Offer a very short reply. 0.6. What is the ratio of the Cost of communications, computer etc. (% of service imports) in Venezuela in 2006 to that in 2012?
Your response must be concise. 0.56. What is the ratio of the Cost of communications, computer etc. (% of service imports) in Argentina in 2007 to that in 2008?
Give a very brief answer. 0.97. What is the ratio of the Cost of communications, computer etc. (% of service imports) of Belarus in 2007 to that in 2008?
Keep it short and to the point. 1.03. What is the ratio of the Cost of communications, computer etc. (% of service imports) of Venezuela in 2007 to that in 2008?
Your answer should be very brief. 0.96. What is the ratio of the Cost of communications, computer etc. (% of service imports) of Argentina in 2007 to that in 2009?
Your answer should be compact. 0.85. What is the ratio of the Cost of communications, computer etc. (% of service imports) in Belarus in 2007 to that in 2009?
Keep it short and to the point. 0.85. What is the ratio of the Cost of communications, computer etc. (% of service imports) of Venezuela in 2007 to that in 2009?
Offer a very short reply. 0.87. What is the ratio of the Cost of communications, computer etc. (% of service imports) of Argentina in 2007 to that in 2010?
Ensure brevity in your answer.  0.83. What is the ratio of the Cost of communications, computer etc. (% of service imports) in Belarus in 2007 to that in 2010?
Your answer should be compact. 0.84. What is the ratio of the Cost of communications, computer etc. (% of service imports) of Venezuela in 2007 to that in 2010?
Offer a terse response. 0.79. What is the ratio of the Cost of communications, computer etc. (% of service imports) of Argentina in 2007 to that in 2011?
Your answer should be compact. 0.8. What is the ratio of the Cost of communications, computer etc. (% of service imports) in Belarus in 2007 to that in 2011?
Make the answer very short. 0.75. What is the ratio of the Cost of communications, computer etc. (% of service imports) in Venezuela in 2007 to that in 2011?
Your answer should be very brief. 0.84. What is the ratio of the Cost of communications, computer etc. (% of service imports) of Argentina in 2007 to that in 2012?
Provide a short and direct response. 0.79. What is the ratio of the Cost of communications, computer etc. (% of service imports) of Belarus in 2007 to that in 2012?
Keep it short and to the point. 0.64. What is the ratio of the Cost of communications, computer etc. (% of service imports) of Venezuela in 2007 to that in 2012?
Ensure brevity in your answer.  0.89. What is the ratio of the Cost of communications, computer etc. (% of service imports) of Argentina in 2008 to that in 2009?
Your response must be concise. 0.88. What is the ratio of the Cost of communications, computer etc. (% of service imports) of Belarus in 2008 to that in 2009?
Ensure brevity in your answer.  0.83. What is the ratio of the Cost of communications, computer etc. (% of service imports) in Venezuela in 2008 to that in 2009?
Your response must be concise. 0.91. What is the ratio of the Cost of communications, computer etc. (% of service imports) of Argentina in 2008 to that in 2010?
Keep it short and to the point. 0.86. What is the ratio of the Cost of communications, computer etc. (% of service imports) in Belarus in 2008 to that in 2010?
Make the answer very short. 0.82. What is the ratio of the Cost of communications, computer etc. (% of service imports) of Venezuela in 2008 to that in 2010?
Your answer should be very brief. 0.82. What is the ratio of the Cost of communications, computer etc. (% of service imports) of Argentina in 2008 to that in 2011?
Your answer should be compact. 0.83. What is the ratio of the Cost of communications, computer etc. (% of service imports) in Belarus in 2008 to that in 2011?
Your response must be concise. 0.73. What is the ratio of the Cost of communications, computer etc. (% of service imports) in Venezuela in 2008 to that in 2011?
Your answer should be compact. 0.88. What is the ratio of the Cost of communications, computer etc. (% of service imports) of Argentina in 2008 to that in 2012?
Offer a very short reply. 0.82. What is the ratio of the Cost of communications, computer etc. (% of service imports) in Belarus in 2008 to that in 2012?
Make the answer very short. 0.62. What is the ratio of the Cost of communications, computer etc. (% of service imports) of Venezuela in 2008 to that in 2012?
Offer a very short reply. 0.93. What is the ratio of the Cost of communications, computer etc. (% of service imports) of Argentina in 2009 to that in 2010?
Provide a short and direct response. 0.98. What is the ratio of the Cost of communications, computer etc. (% of service imports) of Belarus in 2009 to that in 2010?
Give a very brief answer. 0.99. What is the ratio of the Cost of communications, computer etc. (% of service imports) in Venezuela in 2009 to that in 2010?
Your response must be concise. 0.9. What is the ratio of the Cost of communications, computer etc. (% of service imports) in Argentina in 2009 to that in 2011?
Keep it short and to the point. 0.94. What is the ratio of the Cost of communications, computer etc. (% of service imports) in Belarus in 2009 to that in 2011?
Your response must be concise. 0.88. What is the ratio of the Cost of communications, computer etc. (% of service imports) of Venezuela in 2009 to that in 2011?
Ensure brevity in your answer.  0.96. What is the ratio of the Cost of communications, computer etc. (% of service imports) of Argentina in 2009 to that in 2012?
Give a very brief answer. 0.93. What is the ratio of the Cost of communications, computer etc. (% of service imports) in Belarus in 2009 to that in 2012?
Offer a terse response. 0.76. What is the ratio of the Cost of communications, computer etc. (% of service imports) in Argentina in 2010 to that in 2011?
Your answer should be very brief. 0.97. What is the ratio of the Cost of communications, computer etc. (% of service imports) in Belarus in 2010 to that in 2011?
Your answer should be compact. 0.89. What is the ratio of the Cost of communications, computer etc. (% of service imports) of Venezuela in 2010 to that in 2011?
Ensure brevity in your answer.  1.06. What is the ratio of the Cost of communications, computer etc. (% of service imports) of Argentina in 2010 to that in 2012?
Your response must be concise. 0.95. What is the ratio of the Cost of communications, computer etc. (% of service imports) in Belarus in 2010 to that in 2012?
Your response must be concise. 0.76. What is the ratio of the Cost of communications, computer etc. (% of service imports) of Venezuela in 2010 to that in 2012?
Provide a short and direct response. 1.13. What is the ratio of the Cost of communications, computer etc. (% of service imports) of Argentina in 2011 to that in 2012?
Ensure brevity in your answer.  0.99. What is the ratio of the Cost of communications, computer etc. (% of service imports) of Belarus in 2011 to that in 2012?
Provide a succinct answer. 0.86. What is the ratio of the Cost of communications, computer etc. (% of service imports) of Venezuela in 2011 to that in 2012?
Keep it short and to the point. 1.06. What is the difference between the highest and the second highest Cost of communications, computer etc. (% of service imports) of Argentina?
Offer a very short reply. 0.49. What is the difference between the highest and the second highest Cost of communications, computer etc. (% of service imports) of Belarus?
Provide a succinct answer. 5.26. What is the difference between the highest and the second highest Cost of communications, computer etc. (% of service imports) of Venezuela?
Provide a short and direct response. 3.16. What is the difference between the highest and the lowest Cost of communications, computer etc. (% of service imports) in Argentina?
Your answer should be compact. 8.05. What is the difference between the highest and the lowest Cost of communications, computer etc. (% of service imports) of Belarus?
Your answer should be compact. 14.99. What is the difference between the highest and the lowest Cost of communications, computer etc. (% of service imports) of Venezuela?
Your response must be concise. 26.18. 